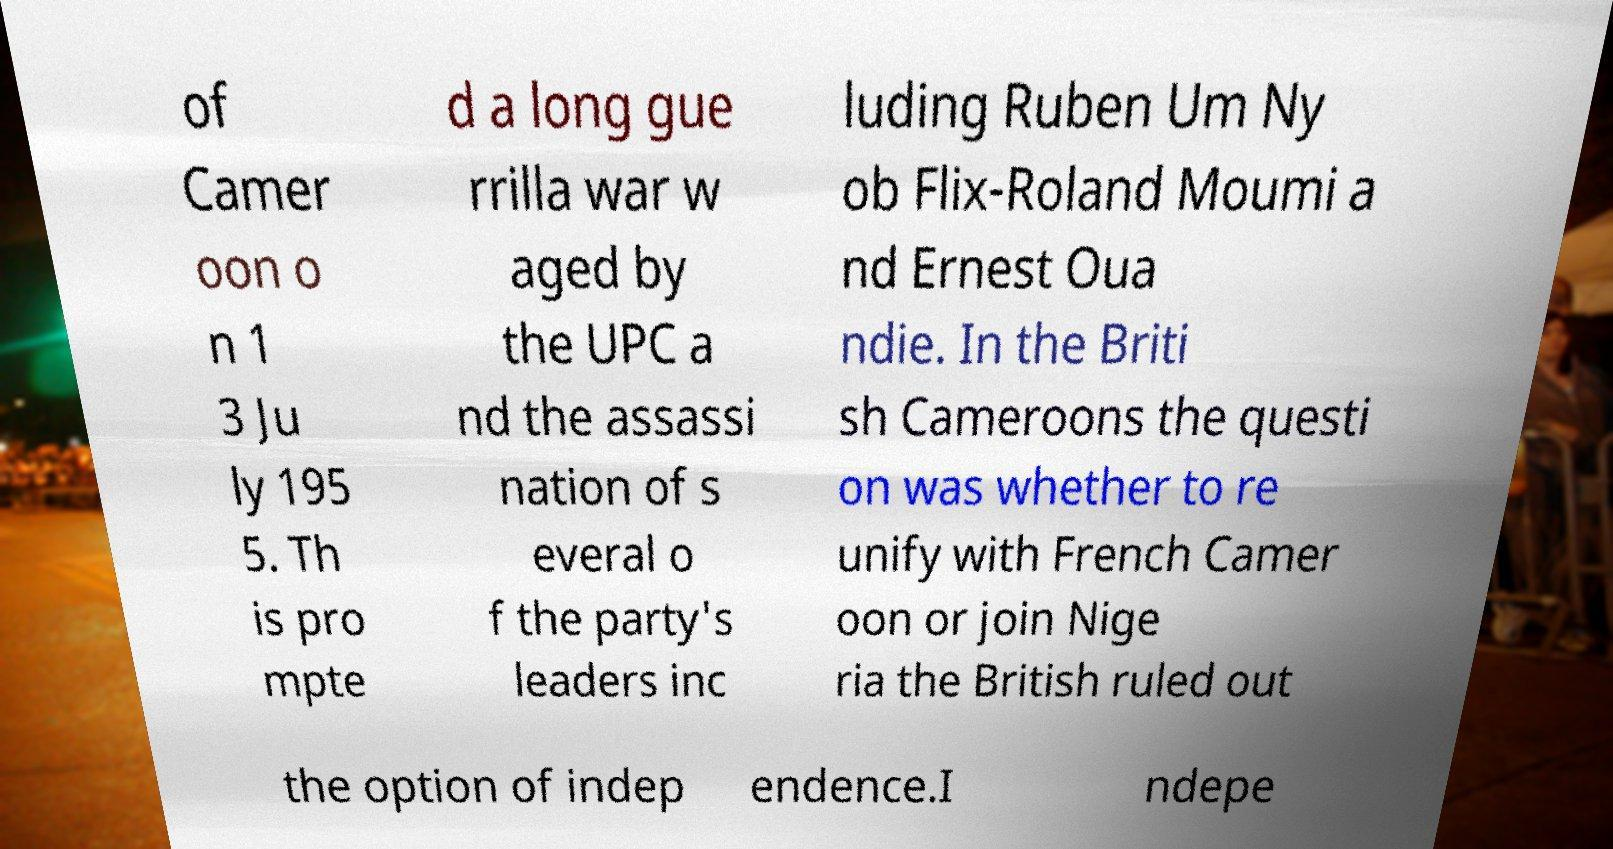Could you assist in decoding the text presented in this image and type it out clearly? of Camer oon o n 1 3 Ju ly 195 5. Th is pro mpte d a long gue rrilla war w aged by the UPC a nd the assassi nation of s everal o f the party's leaders inc luding Ruben Um Ny ob Flix-Roland Moumi a nd Ernest Oua ndie. In the Briti sh Cameroons the questi on was whether to re unify with French Camer oon or join Nige ria the British ruled out the option of indep endence.I ndepe 